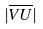<formula> <loc_0><loc_0><loc_500><loc_500>| \overline { V U } |</formula> 